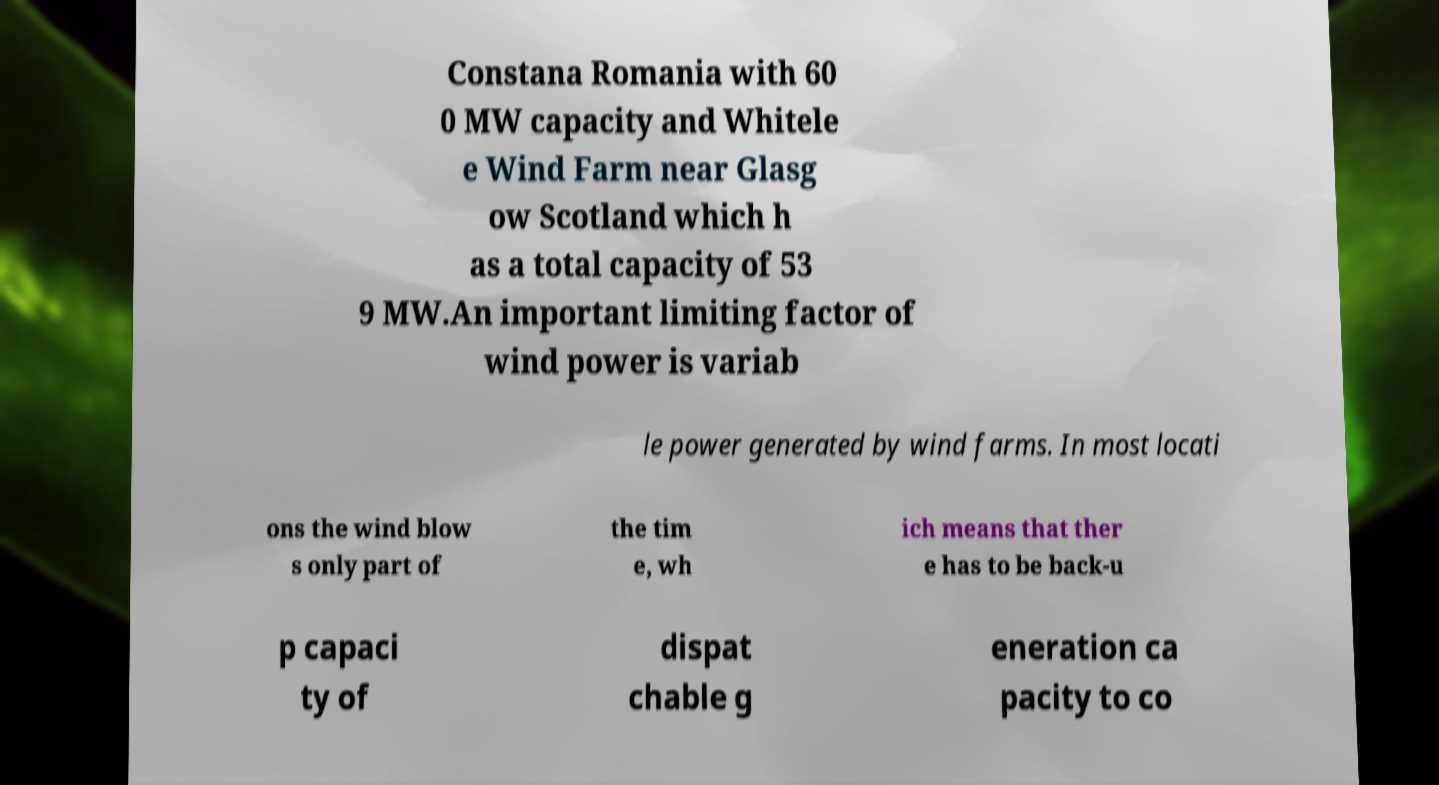For documentation purposes, I need the text within this image transcribed. Could you provide that? Constana Romania with 60 0 MW capacity and Whitele e Wind Farm near Glasg ow Scotland which h as a total capacity of 53 9 MW.An important limiting factor of wind power is variab le power generated by wind farms. In most locati ons the wind blow s only part of the tim e, wh ich means that ther e has to be back-u p capaci ty of dispat chable g eneration ca pacity to co 